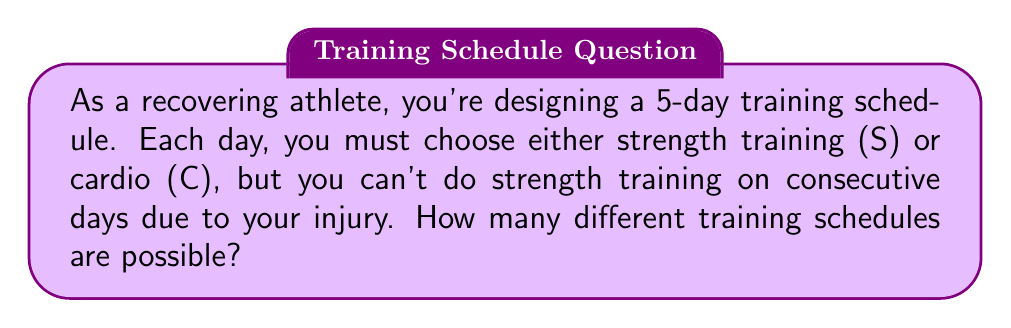Solve this math problem. Let's approach this step-by-step:

1) We need to fill 5 slots with either S or C, but S can't appear on consecutive days.

2) Let's start by considering the possible patterns:
   - C can be in any position
   - S must have at least one C between each occurrence

3) We can represent this as a binary string problem where:
   - C = 0
   - S = 1
   And we need to avoid consecutive 1's.

4) This is a well-known problem in combinatorics. The number of binary strings of length n without consecutive 1's is given by the (n+2)th Fibonacci number.

5) The Fibonacci sequence starts: 1, 1, 2, 3, 5, 8, 13, ...

6) We need the 7th Fibonacci number (5+2 = 7).

7) We can calculate this:
   $$F_7 = F_6 + F_5 = 8 + 5 = 13$$

Therefore, there are 13 possible training schedules that satisfy the conditions.

To verify, we can list all possibilities:
CCCCC, CCCCС, CCCSC, CCСCC, CCСSC, CSCCC, CSCSC, SCCCC, SCCSC, SCСCC, SCСSC, SCSCC, SCSCC

Indeed, there are 13 possibilities.
Answer: 13 